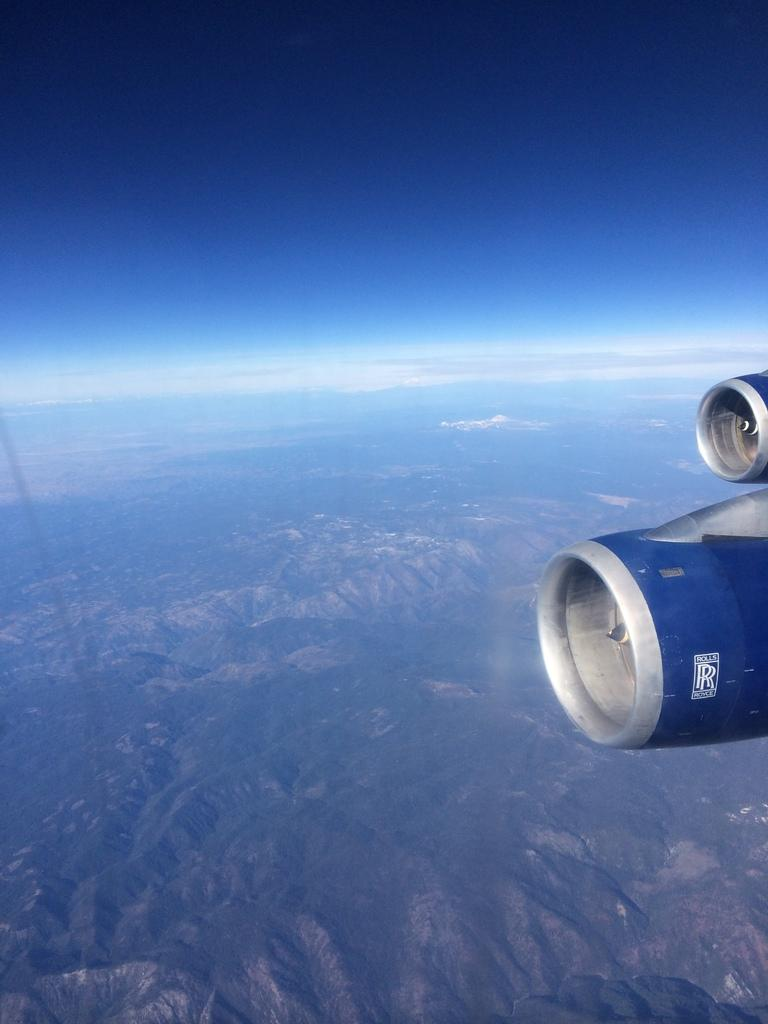What is the main subject of the image? The main subject of the image is an airplane. What feature can be seen on the airplane? The airplane has a propeller. Where is the airplane located in the image? The airplane is flying in the sky. Where is the shop located in the image? There is no shop present in the image; it features an airplane flying in the sky. Can you see any volleyball players in the image? There are no volleyball players or any reference to volleyball in the image. 